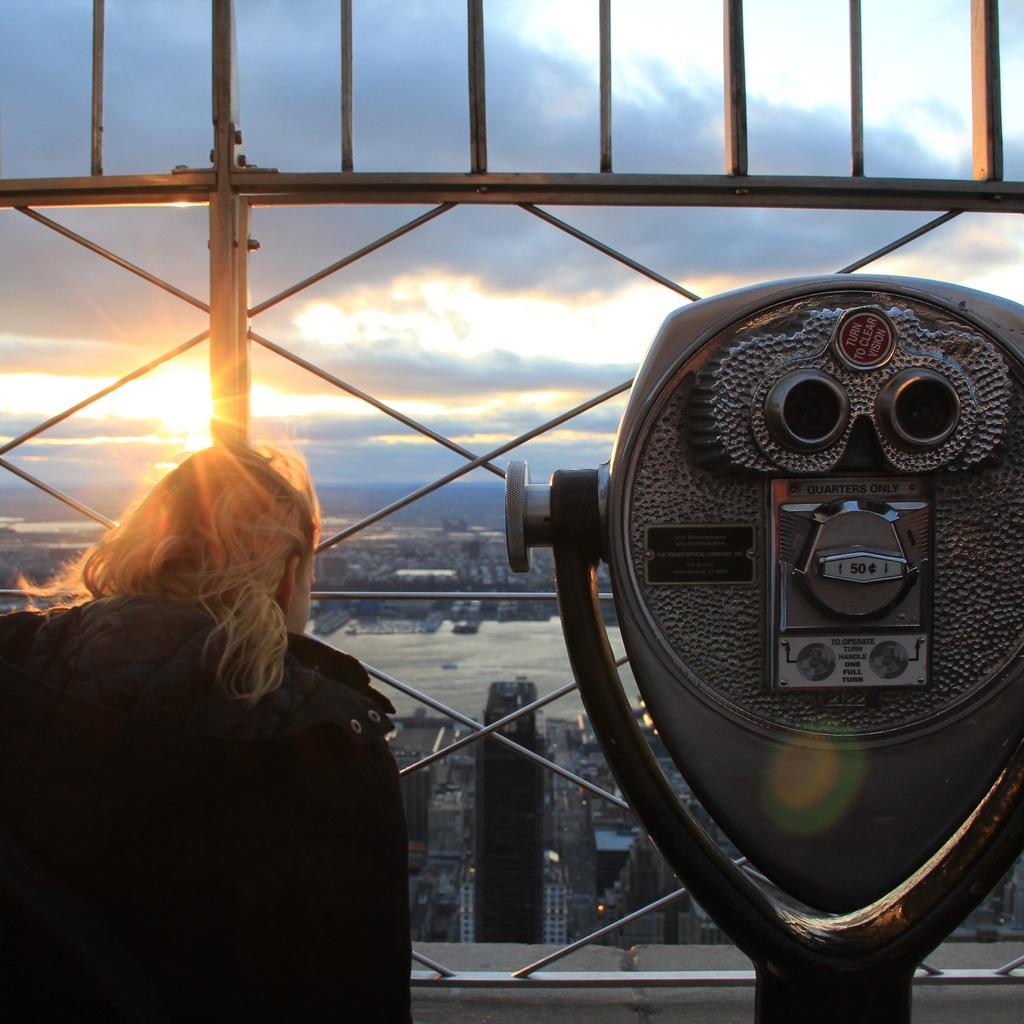What is the person standing in front of in the image? The person is standing in front of the grilles. What else can be seen near the grilles? There is a machine placed next to the grilles. What type of nose can be seen on the cattle in the image? There are no cattle present in the image, so there is no nose to observe. What sound do the bells make in the image? There are no bells present in the image, so there is no sound to describe. 